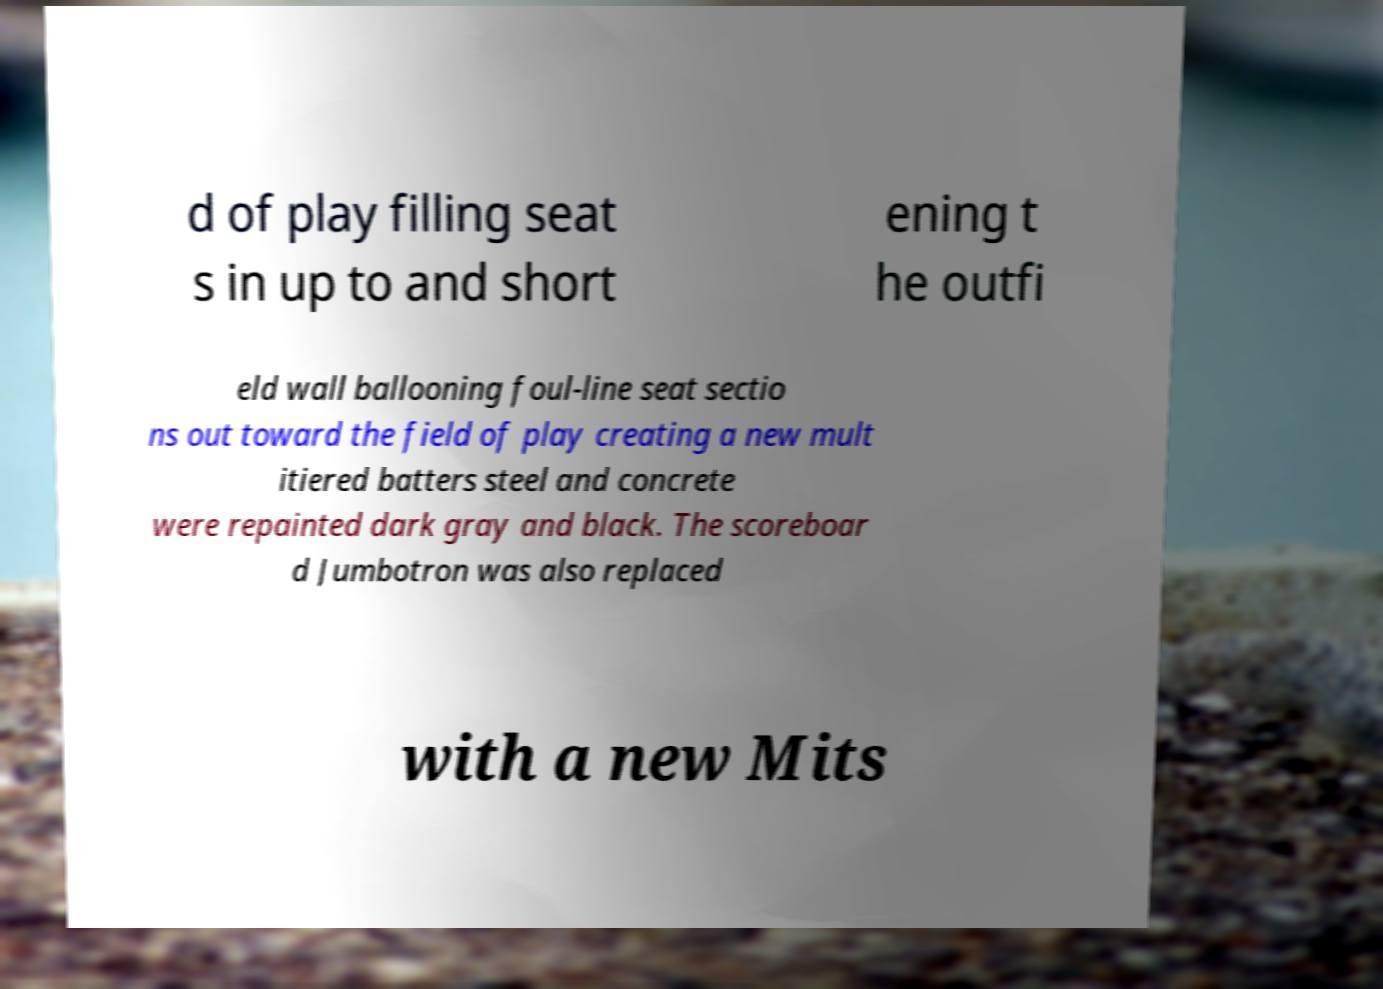Can you read and provide the text displayed in the image?This photo seems to have some interesting text. Can you extract and type it out for me? d of play filling seat s in up to and short ening t he outfi eld wall ballooning foul-line seat sectio ns out toward the field of play creating a new mult itiered batters steel and concrete were repainted dark gray and black. The scoreboar d Jumbotron was also replaced with a new Mits 